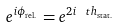<formula> <loc_0><loc_0><loc_500><loc_500>e ^ { i \phi _ { \text {rel.} } } = e ^ { 2 i \ t h _ { \text {stat.} } }</formula> 